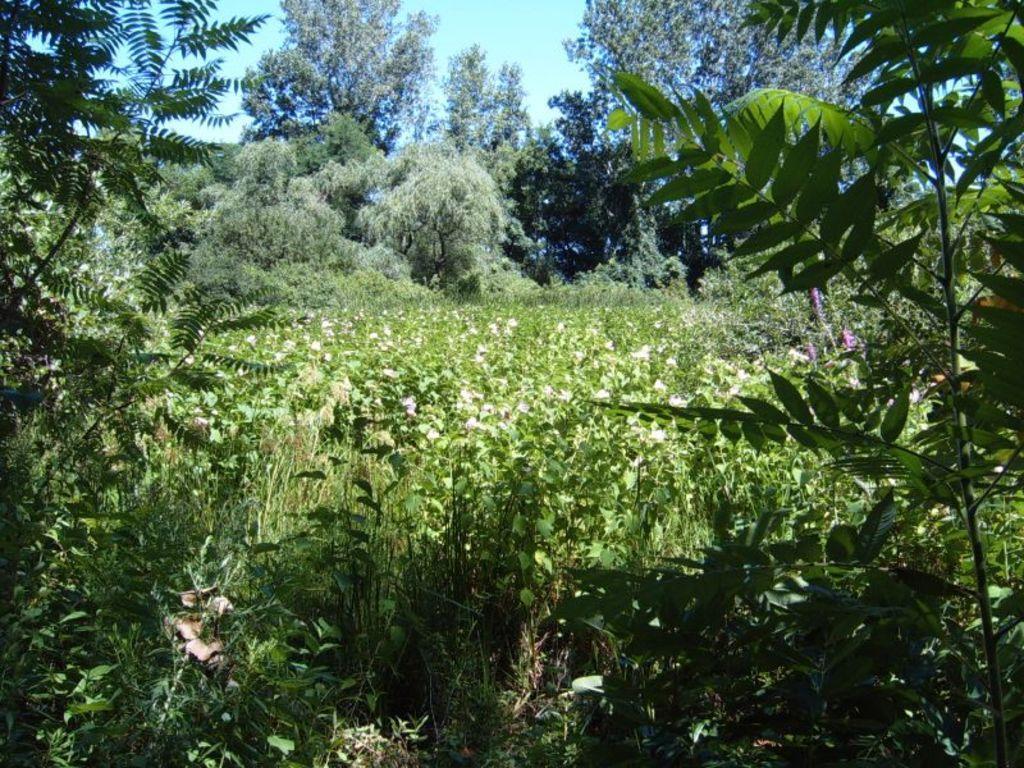How would you summarize this image in a sentence or two? In the foreground of this image, there are plants and trees and in the background, there are flowers, trees, plants and the sky. 